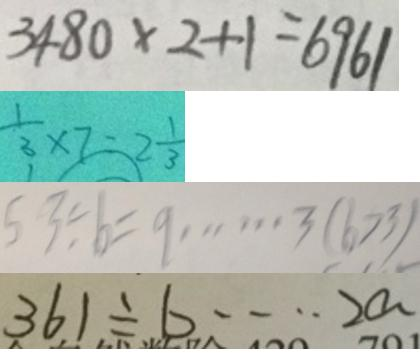<formula> <loc_0><loc_0><loc_500><loc_500>3 4 8 0 \times 2 + 1 = 6 9 6 1 
 \frac { 1 } { 3 } \times 7 = 2 \frac { 1 } { 3 } 
 5 3 \div b = 9 \cdots 3 ( b > 3 ) 
 3 6 1 \div b \cdots 2 a</formula> 